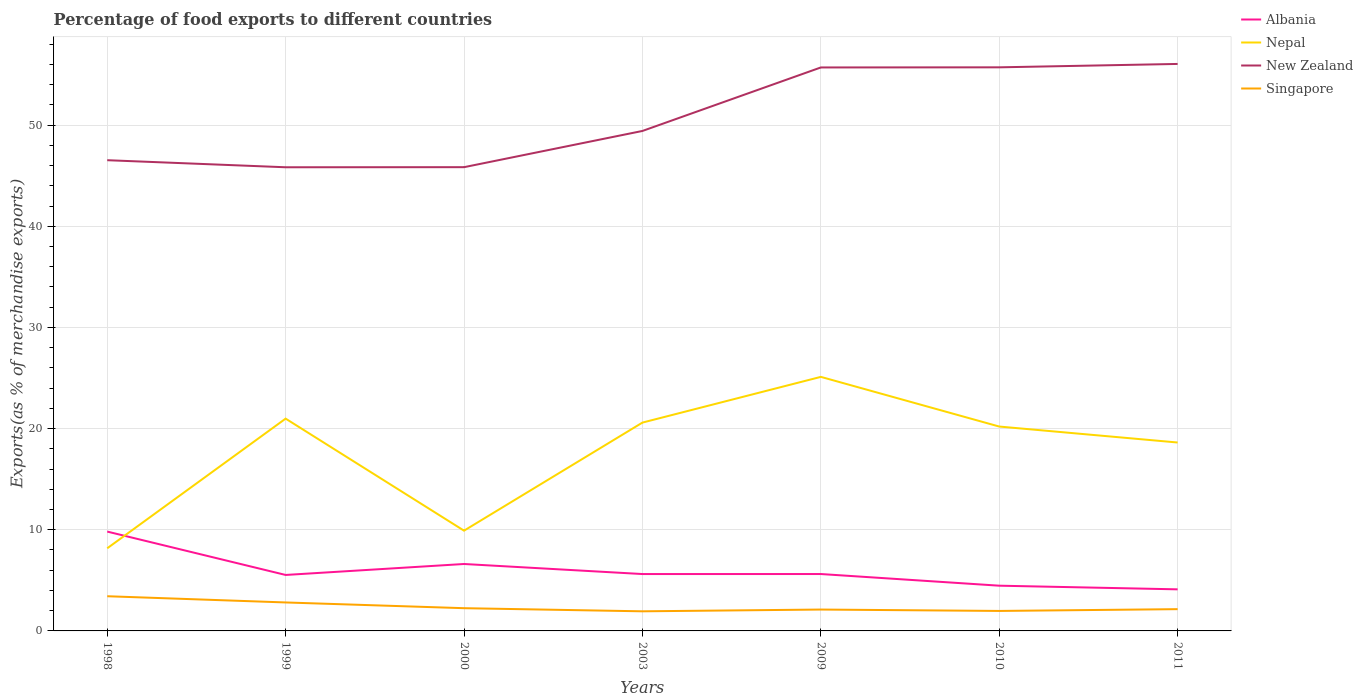Is the number of lines equal to the number of legend labels?
Give a very brief answer. Yes. Across all years, what is the maximum percentage of exports to different countries in New Zealand?
Make the answer very short. 45.83. What is the total percentage of exports to different countries in Nepal in the graph?
Offer a terse response. 0.78. What is the difference between the highest and the second highest percentage of exports to different countries in Albania?
Offer a terse response. 5.71. What is the difference between the highest and the lowest percentage of exports to different countries in Albania?
Provide a short and direct response. 2. Is the percentage of exports to different countries in Albania strictly greater than the percentage of exports to different countries in Nepal over the years?
Provide a succinct answer. No. What is the difference between two consecutive major ticks on the Y-axis?
Your response must be concise. 10. Are the values on the major ticks of Y-axis written in scientific E-notation?
Your answer should be compact. No. Does the graph contain grids?
Your response must be concise. Yes. How many legend labels are there?
Offer a very short reply. 4. How are the legend labels stacked?
Provide a short and direct response. Vertical. What is the title of the graph?
Provide a short and direct response. Percentage of food exports to different countries. What is the label or title of the Y-axis?
Offer a very short reply. Exports(as % of merchandise exports). What is the Exports(as % of merchandise exports) in Albania in 1998?
Make the answer very short. 9.82. What is the Exports(as % of merchandise exports) of Nepal in 1998?
Offer a terse response. 8.17. What is the Exports(as % of merchandise exports) of New Zealand in 1998?
Provide a succinct answer. 46.53. What is the Exports(as % of merchandise exports) of Singapore in 1998?
Your answer should be compact. 3.43. What is the Exports(as % of merchandise exports) of Albania in 1999?
Provide a succinct answer. 5.53. What is the Exports(as % of merchandise exports) of Nepal in 1999?
Ensure brevity in your answer.  20.99. What is the Exports(as % of merchandise exports) in New Zealand in 1999?
Your answer should be very brief. 45.83. What is the Exports(as % of merchandise exports) in Singapore in 1999?
Your response must be concise. 2.81. What is the Exports(as % of merchandise exports) in Albania in 2000?
Provide a short and direct response. 6.62. What is the Exports(as % of merchandise exports) of Nepal in 2000?
Make the answer very short. 9.91. What is the Exports(as % of merchandise exports) in New Zealand in 2000?
Provide a succinct answer. 45.84. What is the Exports(as % of merchandise exports) in Singapore in 2000?
Offer a terse response. 2.25. What is the Exports(as % of merchandise exports) of Albania in 2003?
Offer a terse response. 5.62. What is the Exports(as % of merchandise exports) in Nepal in 2003?
Ensure brevity in your answer.  20.59. What is the Exports(as % of merchandise exports) in New Zealand in 2003?
Ensure brevity in your answer.  49.42. What is the Exports(as % of merchandise exports) of Singapore in 2003?
Your response must be concise. 1.94. What is the Exports(as % of merchandise exports) of Albania in 2009?
Provide a short and direct response. 5.62. What is the Exports(as % of merchandise exports) in Nepal in 2009?
Your answer should be compact. 25.11. What is the Exports(as % of merchandise exports) of New Zealand in 2009?
Provide a succinct answer. 55.7. What is the Exports(as % of merchandise exports) in Singapore in 2009?
Ensure brevity in your answer.  2.11. What is the Exports(as % of merchandise exports) in Albania in 2010?
Your answer should be very brief. 4.47. What is the Exports(as % of merchandise exports) in Nepal in 2010?
Offer a terse response. 20.2. What is the Exports(as % of merchandise exports) of New Zealand in 2010?
Offer a terse response. 55.71. What is the Exports(as % of merchandise exports) of Singapore in 2010?
Your answer should be very brief. 1.98. What is the Exports(as % of merchandise exports) in Albania in 2011?
Provide a short and direct response. 4.11. What is the Exports(as % of merchandise exports) in Nepal in 2011?
Your answer should be compact. 18.63. What is the Exports(as % of merchandise exports) in New Zealand in 2011?
Your answer should be very brief. 56.05. What is the Exports(as % of merchandise exports) in Singapore in 2011?
Offer a very short reply. 2.15. Across all years, what is the maximum Exports(as % of merchandise exports) in Albania?
Offer a terse response. 9.82. Across all years, what is the maximum Exports(as % of merchandise exports) of Nepal?
Offer a terse response. 25.11. Across all years, what is the maximum Exports(as % of merchandise exports) of New Zealand?
Keep it short and to the point. 56.05. Across all years, what is the maximum Exports(as % of merchandise exports) of Singapore?
Ensure brevity in your answer.  3.43. Across all years, what is the minimum Exports(as % of merchandise exports) of Albania?
Your answer should be very brief. 4.11. Across all years, what is the minimum Exports(as % of merchandise exports) of Nepal?
Keep it short and to the point. 8.17. Across all years, what is the minimum Exports(as % of merchandise exports) in New Zealand?
Your response must be concise. 45.83. Across all years, what is the minimum Exports(as % of merchandise exports) in Singapore?
Keep it short and to the point. 1.94. What is the total Exports(as % of merchandise exports) in Albania in the graph?
Your response must be concise. 41.8. What is the total Exports(as % of merchandise exports) in Nepal in the graph?
Your response must be concise. 123.61. What is the total Exports(as % of merchandise exports) of New Zealand in the graph?
Your response must be concise. 355.1. What is the total Exports(as % of merchandise exports) in Singapore in the graph?
Ensure brevity in your answer.  16.67. What is the difference between the Exports(as % of merchandise exports) in Albania in 1998 and that in 1999?
Make the answer very short. 4.29. What is the difference between the Exports(as % of merchandise exports) of Nepal in 1998 and that in 1999?
Provide a succinct answer. -12.82. What is the difference between the Exports(as % of merchandise exports) in New Zealand in 1998 and that in 1999?
Ensure brevity in your answer.  0.7. What is the difference between the Exports(as % of merchandise exports) in Singapore in 1998 and that in 1999?
Keep it short and to the point. 0.61. What is the difference between the Exports(as % of merchandise exports) in Albania in 1998 and that in 2000?
Ensure brevity in your answer.  3.2. What is the difference between the Exports(as % of merchandise exports) of Nepal in 1998 and that in 2000?
Your answer should be compact. -1.74. What is the difference between the Exports(as % of merchandise exports) in New Zealand in 1998 and that in 2000?
Keep it short and to the point. 0.69. What is the difference between the Exports(as % of merchandise exports) of Singapore in 1998 and that in 2000?
Your response must be concise. 1.18. What is the difference between the Exports(as % of merchandise exports) in Albania in 1998 and that in 2003?
Ensure brevity in your answer.  4.2. What is the difference between the Exports(as % of merchandise exports) of Nepal in 1998 and that in 2003?
Your response must be concise. -12.42. What is the difference between the Exports(as % of merchandise exports) of New Zealand in 1998 and that in 2003?
Provide a succinct answer. -2.89. What is the difference between the Exports(as % of merchandise exports) in Singapore in 1998 and that in 2003?
Offer a terse response. 1.49. What is the difference between the Exports(as % of merchandise exports) of Albania in 1998 and that in 2009?
Offer a terse response. 4.2. What is the difference between the Exports(as % of merchandise exports) in Nepal in 1998 and that in 2009?
Your response must be concise. -16.95. What is the difference between the Exports(as % of merchandise exports) of New Zealand in 1998 and that in 2009?
Provide a short and direct response. -9.17. What is the difference between the Exports(as % of merchandise exports) in Singapore in 1998 and that in 2009?
Your response must be concise. 1.32. What is the difference between the Exports(as % of merchandise exports) of Albania in 1998 and that in 2010?
Ensure brevity in your answer.  5.35. What is the difference between the Exports(as % of merchandise exports) in Nepal in 1998 and that in 2010?
Keep it short and to the point. -12.04. What is the difference between the Exports(as % of merchandise exports) of New Zealand in 1998 and that in 2010?
Make the answer very short. -9.18. What is the difference between the Exports(as % of merchandise exports) of Singapore in 1998 and that in 2010?
Ensure brevity in your answer.  1.45. What is the difference between the Exports(as % of merchandise exports) of Albania in 1998 and that in 2011?
Offer a very short reply. 5.71. What is the difference between the Exports(as % of merchandise exports) in Nepal in 1998 and that in 2011?
Your answer should be compact. -10.46. What is the difference between the Exports(as % of merchandise exports) of New Zealand in 1998 and that in 2011?
Keep it short and to the point. -9.52. What is the difference between the Exports(as % of merchandise exports) in Singapore in 1998 and that in 2011?
Make the answer very short. 1.28. What is the difference between the Exports(as % of merchandise exports) of Albania in 1999 and that in 2000?
Make the answer very short. -1.08. What is the difference between the Exports(as % of merchandise exports) of Nepal in 1999 and that in 2000?
Your response must be concise. 11.08. What is the difference between the Exports(as % of merchandise exports) of New Zealand in 1999 and that in 2000?
Offer a very short reply. -0.01. What is the difference between the Exports(as % of merchandise exports) in Singapore in 1999 and that in 2000?
Your answer should be compact. 0.57. What is the difference between the Exports(as % of merchandise exports) in Albania in 1999 and that in 2003?
Ensure brevity in your answer.  -0.09. What is the difference between the Exports(as % of merchandise exports) in Nepal in 1999 and that in 2003?
Give a very brief answer. 0.39. What is the difference between the Exports(as % of merchandise exports) of New Zealand in 1999 and that in 2003?
Offer a very short reply. -3.59. What is the difference between the Exports(as % of merchandise exports) in Singapore in 1999 and that in 2003?
Offer a very short reply. 0.88. What is the difference between the Exports(as % of merchandise exports) of Albania in 1999 and that in 2009?
Your response must be concise. -0.09. What is the difference between the Exports(as % of merchandise exports) in Nepal in 1999 and that in 2009?
Give a very brief answer. -4.13. What is the difference between the Exports(as % of merchandise exports) in New Zealand in 1999 and that in 2009?
Give a very brief answer. -9.87. What is the difference between the Exports(as % of merchandise exports) of Singapore in 1999 and that in 2009?
Your answer should be very brief. 0.7. What is the difference between the Exports(as % of merchandise exports) of Albania in 1999 and that in 2010?
Give a very brief answer. 1.06. What is the difference between the Exports(as % of merchandise exports) in Nepal in 1999 and that in 2010?
Keep it short and to the point. 0.78. What is the difference between the Exports(as % of merchandise exports) in New Zealand in 1999 and that in 2010?
Your response must be concise. -9.88. What is the difference between the Exports(as % of merchandise exports) of Singapore in 1999 and that in 2010?
Ensure brevity in your answer.  0.84. What is the difference between the Exports(as % of merchandise exports) of Albania in 1999 and that in 2011?
Provide a short and direct response. 1.42. What is the difference between the Exports(as % of merchandise exports) of Nepal in 1999 and that in 2011?
Offer a terse response. 2.36. What is the difference between the Exports(as % of merchandise exports) in New Zealand in 1999 and that in 2011?
Provide a short and direct response. -10.21. What is the difference between the Exports(as % of merchandise exports) in Singapore in 1999 and that in 2011?
Provide a short and direct response. 0.66. What is the difference between the Exports(as % of merchandise exports) of Albania in 2000 and that in 2003?
Give a very brief answer. 0.99. What is the difference between the Exports(as % of merchandise exports) of Nepal in 2000 and that in 2003?
Your response must be concise. -10.68. What is the difference between the Exports(as % of merchandise exports) in New Zealand in 2000 and that in 2003?
Keep it short and to the point. -3.58. What is the difference between the Exports(as % of merchandise exports) of Singapore in 2000 and that in 2003?
Keep it short and to the point. 0.31. What is the difference between the Exports(as % of merchandise exports) of Nepal in 2000 and that in 2009?
Keep it short and to the point. -15.2. What is the difference between the Exports(as % of merchandise exports) of New Zealand in 2000 and that in 2009?
Offer a very short reply. -9.86. What is the difference between the Exports(as % of merchandise exports) in Singapore in 2000 and that in 2009?
Offer a terse response. 0.14. What is the difference between the Exports(as % of merchandise exports) of Albania in 2000 and that in 2010?
Your response must be concise. 2.14. What is the difference between the Exports(as % of merchandise exports) of Nepal in 2000 and that in 2010?
Provide a succinct answer. -10.29. What is the difference between the Exports(as % of merchandise exports) of New Zealand in 2000 and that in 2010?
Offer a very short reply. -9.87. What is the difference between the Exports(as % of merchandise exports) of Singapore in 2000 and that in 2010?
Give a very brief answer. 0.27. What is the difference between the Exports(as % of merchandise exports) in Albania in 2000 and that in 2011?
Give a very brief answer. 2.51. What is the difference between the Exports(as % of merchandise exports) of Nepal in 2000 and that in 2011?
Your answer should be compact. -8.71. What is the difference between the Exports(as % of merchandise exports) in New Zealand in 2000 and that in 2011?
Your answer should be very brief. -10.21. What is the difference between the Exports(as % of merchandise exports) in Singapore in 2000 and that in 2011?
Provide a short and direct response. 0.1. What is the difference between the Exports(as % of merchandise exports) of Albania in 2003 and that in 2009?
Provide a short and direct response. -0. What is the difference between the Exports(as % of merchandise exports) of Nepal in 2003 and that in 2009?
Give a very brief answer. -4.52. What is the difference between the Exports(as % of merchandise exports) of New Zealand in 2003 and that in 2009?
Make the answer very short. -6.28. What is the difference between the Exports(as % of merchandise exports) in Singapore in 2003 and that in 2009?
Provide a succinct answer. -0.17. What is the difference between the Exports(as % of merchandise exports) of Albania in 2003 and that in 2010?
Provide a succinct answer. 1.15. What is the difference between the Exports(as % of merchandise exports) of Nepal in 2003 and that in 2010?
Ensure brevity in your answer.  0.39. What is the difference between the Exports(as % of merchandise exports) in New Zealand in 2003 and that in 2010?
Provide a short and direct response. -6.29. What is the difference between the Exports(as % of merchandise exports) of Singapore in 2003 and that in 2010?
Provide a succinct answer. -0.04. What is the difference between the Exports(as % of merchandise exports) of Albania in 2003 and that in 2011?
Give a very brief answer. 1.51. What is the difference between the Exports(as % of merchandise exports) of Nepal in 2003 and that in 2011?
Offer a very short reply. 1.97. What is the difference between the Exports(as % of merchandise exports) in New Zealand in 2003 and that in 2011?
Give a very brief answer. -6.62. What is the difference between the Exports(as % of merchandise exports) in Singapore in 2003 and that in 2011?
Offer a very short reply. -0.21. What is the difference between the Exports(as % of merchandise exports) of Albania in 2009 and that in 2010?
Your response must be concise. 1.15. What is the difference between the Exports(as % of merchandise exports) in Nepal in 2009 and that in 2010?
Ensure brevity in your answer.  4.91. What is the difference between the Exports(as % of merchandise exports) of New Zealand in 2009 and that in 2010?
Your response must be concise. -0.01. What is the difference between the Exports(as % of merchandise exports) of Singapore in 2009 and that in 2010?
Your response must be concise. 0.14. What is the difference between the Exports(as % of merchandise exports) of Albania in 2009 and that in 2011?
Your answer should be very brief. 1.51. What is the difference between the Exports(as % of merchandise exports) of Nepal in 2009 and that in 2011?
Your answer should be very brief. 6.49. What is the difference between the Exports(as % of merchandise exports) in New Zealand in 2009 and that in 2011?
Give a very brief answer. -0.35. What is the difference between the Exports(as % of merchandise exports) of Singapore in 2009 and that in 2011?
Give a very brief answer. -0.04. What is the difference between the Exports(as % of merchandise exports) of Albania in 2010 and that in 2011?
Ensure brevity in your answer.  0.36. What is the difference between the Exports(as % of merchandise exports) in Nepal in 2010 and that in 2011?
Your answer should be very brief. 1.58. What is the difference between the Exports(as % of merchandise exports) of New Zealand in 2010 and that in 2011?
Offer a terse response. -0.33. What is the difference between the Exports(as % of merchandise exports) of Singapore in 2010 and that in 2011?
Keep it short and to the point. -0.18. What is the difference between the Exports(as % of merchandise exports) in Albania in 1998 and the Exports(as % of merchandise exports) in Nepal in 1999?
Keep it short and to the point. -11.17. What is the difference between the Exports(as % of merchandise exports) of Albania in 1998 and the Exports(as % of merchandise exports) of New Zealand in 1999?
Your response must be concise. -36.01. What is the difference between the Exports(as % of merchandise exports) in Albania in 1998 and the Exports(as % of merchandise exports) in Singapore in 1999?
Make the answer very short. 7.01. What is the difference between the Exports(as % of merchandise exports) in Nepal in 1998 and the Exports(as % of merchandise exports) in New Zealand in 1999?
Offer a terse response. -37.66. What is the difference between the Exports(as % of merchandise exports) in Nepal in 1998 and the Exports(as % of merchandise exports) in Singapore in 1999?
Make the answer very short. 5.36. What is the difference between the Exports(as % of merchandise exports) of New Zealand in 1998 and the Exports(as % of merchandise exports) of Singapore in 1999?
Offer a very short reply. 43.72. What is the difference between the Exports(as % of merchandise exports) of Albania in 1998 and the Exports(as % of merchandise exports) of Nepal in 2000?
Your answer should be compact. -0.09. What is the difference between the Exports(as % of merchandise exports) in Albania in 1998 and the Exports(as % of merchandise exports) in New Zealand in 2000?
Offer a very short reply. -36.02. What is the difference between the Exports(as % of merchandise exports) of Albania in 1998 and the Exports(as % of merchandise exports) of Singapore in 2000?
Offer a very short reply. 7.57. What is the difference between the Exports(as % of merchandise exports) in Nepal in 1998 and the Exports(as % of merchandise exports) in New Zealand in 2000?
Give a very brief answer. -37.67. What is the difference between the Exports(as % of merchandise exports) of Nepal in 1998 and the Exports(as % of merchandise exports) of Singapore in 2000?
Your response must be concise. 5.92. What is the difference between the Exports(as % of merchandise exports) in New Zealand in 1998 and the Exports(as % of merchandise exports) in Singapore in 2000?
Your answer should be compact. 44.29. What is the difference between the Exports(as % of merchandise exports) of Albania in 1998 and the Exports(as % of merchandise exports) of Nepal in 2003?
Offer a very short reply. -10.77. What is the difference between the Exports(as % of merchandise exports) in Albania in 1998 and the Exports(as % of merchandise exports) in New Zealand in 2003?
Offer a terse response. -39.6. What is the difference between the Exports(as % of merchandise exports) in Albania in 1998 and the Exports(as % of merchandise exports) in Singapore in 2003?
Your response must be concise. 7.88. What is the difference between the Exports(as % of merchandise exports) of Nepal in 1998 and the Exports(as % of merchandise exports) of New Zealand in 2003?
Offer a very short reply. -41.26. What is the difference between the Exports(as % of merchandise exports) in Nepal in 1998 and the Exports(as % of merchandise exports) in Singapore in 2003?
Ensure brevity in your answer.  6.23. What is the difference between the Exports(as % of merchandise exports) in New Zealand in 1998 and the Exports(as % of merchandise exports) in Singapore in 2003?
Provide a succinct answer. 44.59. What is the difference between the Exports(as % of merchandise exports) in Albania in 1998 and the Exports(as % of merchandise exports) in Nepal in 2009?
Give a very brief answer. -15.29. What is the difference between the Exports(as % of merchandise exports) in Albania in 1998 and the Exports(as % of merchandise exports) in New Zealand in 2009?
Offer a very short reply. -45.88. What is the difference between the Exports(as % of merchandise exports) in Albania in 1998 and the Exports(as % of merchandise exports) in Singapore in 2009?
Provide a succinct answer. 7.71. What is the difference between the Exports(as % of merchandise exports) in Nepal in 1998 and the Exports(as % of merchandise exports) in New Zealand in 2009?
Offer a terse response. -47.53. What is the difference between the Exports(as % of merchandise exports) of Nepal in 1998 and the Exports(as % of merchandise exports) of Singapore in 2009?
Offer a very short reply. 6.06. What is the difference between the Exports(as % of merchandise exports) of New Zealand in 1998 and the Exports(as % of merchandise exports) of Singapore in 2009?
Your response must be concise. 44.42. What is the difference between the Exports(as % of merchandise exports) of Albania in 1998 and the Exports(as % of merchandise exports) of Nepal in 2010?
Ensure brevity in your answer.  -10.38. What is the difference between the Exports(as % of merchandise exports) of Albania in 1998 and the Exports(as % of merchandise exports) of New Zealand in 2010?
Keep it short and to the point. -45.89. What is the difference between the Exports(as % of merchandise exports) of Albania in 1998 and the Exports(as % of merchandise exports) of Singapore in 2010?
Make the answer very short. 7.84. What is the difference between the Exports(as % of merchandise exports) in Nepal in 1998 and the Exports(as % of merchandise exports) in New Zealand in 2010?
Ensure brevity in your answer.  -47.54. What is the difference between the Exports(as % of merchandise exports) of Nepal in 1998 and the Exports(as % of merchandise exports) of Singapore in 2010?
Make the answer very short. 6.19. What is the difference between the Exports(as % of merchandise exports) in New Zealand in 1998 and the Exports(as % of merchandise exports) in Singapore in 2010?
Provide a short and direct response. 44.56. What is the difference between the Exports(as % of merchandise exports) of Albania in 1998 and the Exports(as % of merchandise exports) of Nepal in 2011?
Your answer should be very brief. -8.8. What is the difference between the Exports(as % of merchandise exports) of Albania in 1998 and the Exports(as % of merchandise exports) of New Zealand in 2011?
Your answer should be very brief. -46.23. What is the difference between the Exports(as % of merchandise exports) in Albania in 1998 and the Exports(as % of merchandise exports) in Singapore in 2011?
Give a very brief answer. 7.67. What is the difference between the Exports(as % of merchandise exports) in Nepal in 1998 and the Exports(as % of merchandise exports) in New Zealand in 2011?
Provide a short and direct response. -47.88. What is the difference between the Exports(as % of merchandise exports) of Nepal in 1998 and the Exports(as % of merchandise exports) of Singapore in 2011?
Make the answer very short. 6.02. What is the difference between the Exports(as % of merchandise exports) of New Zealand in 1998 and the Exports(as % of merchandise exports) of Singapore in 2011?
Your response must be concise. 44.38. What is the difference between the Exports(as % of merchandise exports) of Albania in 1999 and the Exports(as % of merchandise exports) of Nepal in 2000?
Ensure brevity in your answer.  -4.38. What is the difference between the Exports(as % of merchandise exports) in Albania in 1999 and the Exports(as % of merchandise exports) in New Zealand in 2000?
Provide a short and direct response. -40.31. What is the difference between the Exports(as % of merchandise exports) in Albania in 1999 and the Exports(as % of merchandise exports) in Singapore in 2000?
Offer a terse response. 3.29. What is the difference between the Exports(as % of merchandise exports) of Nepal in 1999 and the Exports(as % of merchandise exports) of New Zealand in 2000?
Offer a terse response. -24.86. What is the difference between the Exports(as % of merchandise exports) in Nepal in 1999 and the Exports(as % of merchandise exports) in Singapore in 2000?
Your answer should be very brief. 18.74. What is the difference between the Exports(as % of merchandise exports) of New Zealand in 1999 and the Exports(as % of merchandise exports) of Singapore in 2000?
Your response must be concise. 43.59. What is the difference between the Exports(as % of merchandise exports) of Albania in 1999 and the Exports(as % of merchandise exports) of Nepal in 2003?
Offer a very short reply. -15.06. What is the difference between the Exports(as % of merchandise exports) of Albania in 1999 and the Exports(as % of merchandise exports) of New Zealand in 2003?
Your answer should be compact. -43.89. What is the difference between the Exports(as % of merchandise exports) of Albania in 1999 and the Exports(as % of merchandise exports) of Singapore in 2003?
Make the answer very short. 3.59. What is the difference between the Exports(as % of merchandise exports) of Nepal in 1999 and the Exports(as % of merchandise exports) of New Zealand in 2003?
Offer a very short reply. -28.44. What is the difference between the Exports(as % of merchandise exports) in Nepal in 1999 and the Exports(as % of merchandise exports) in Singapore in 2003?
Keep it short and to the point. 19.05. What is the difference between the Exports(as % of merchandise exports) of New Zealand in 1999 and the Exports(as % of merchandise exports) of Singapore in 2003?
Offer a very short reply. 43.9. What is the difference between the Exports(as % of merchandise exports) of Albania in 1999 and the Exports(as % of merchandise exports) of Nepal in 2009?
Give a very brief answer. -19.58. What is the difference between the Exports(as % of merchandise exports) in Albania in 1999 and the Exports(as % of merchandise exports) in New Zealand in 2009?
Your response must be concise. -50.17. What is the difference between the Exports(as % of merchandise exports) in Albania in 1999 and the Exports(as % of merchandise exports) in Singapore in 2009?
Your response must be concise. 3.42. What is the difference between the Exports(as % of merchandise exports) of Nepal in 1999 and the Exports(as % of merchandise exports) of New Zealand in 2009?
Keep it short and to the point. -34.71. What is the difference between the Exports(as % of merchandise exports) of Nepal in 1999 and the Exports(as % of merchandise exports) of Singapore in 2009?
Your answer should be very brief. 18.87. What is the difference between the Exports(as % of merchandise exports) of New Zealand in 1999 and the Exports(as % of merchandise exports) of Singapore in 2009?
Your answer should be very brief. 43.72. What is the difference between the Exports(as % of merchandise exports) in Albania in 1999 and the Exports(as % of merchandise exports) in Nepal in 2010?
Make the answer very short. -14.67. What is the difference between the Exports(as % of merchandise exports) of Albania in 1999 and the Exports(as % of merchandise exports) of New Zealand in 2010?
Provide a short and direct response. -50.18. What is the difference between the Exports(as % of merchandise exports) in Albania in 1999 and the Exports(as % of merchandise exports) in Singapore in 2010?
Make the answer very short. 3.56. What is the difference between the Exports(as % of merchandise exports) in Nepal in 1999 and the Exports(as % of merchandise exports) in New Zealand in 2010?
Keep it short and to the point. -34.73. What is the difference between the Exports(as % of merchandise exports) of Nepal in 1999 and the Exports(as % of merchandise exports) of Singapore in 2010?
Ensure brevity in your answer.  19.01. What is the difference between the Exports(as % of merchandise exports) of New Zealand in 1999 and the Exports(as % of merchandise exports) of Singapore in 2010?
Offer a very short reply. 43.86. What is the difference between the Exports(as % of merchandise exports) of Albania in 1999 and the Exports(as % of merchandise exports) of Nepal in 2011?
Make the answer very short. -13.09. What is the difference between the Exports(as % of merchandise exports) in Albania in 1999 and the Exports(as % of merchandise exports) in New Zealand in 2011?
Make the answer very short. -50.52. What is the difference between the Exports(as % of merchandise exports) of Albania in 1999 and the Exports(as % of merchandise exports) of Singapore in 2011?
Provide a short and direct response. 3.38. What is the difference between the Exports(as % of merchandise exports) of Nepal in 1999 and the Exports(as % of merchandise exports) of New Zealand in 2011?
Provide a succinct answer. -35.06. What is the difference between the Exports(as % of merchandise exports) of Nepal in 1999 and the Exports(as % of merchandise exports) of Singapore in 2011?
Provide a short and direct response. 18.83. What is the difference between the Exports(as % of merchandise exports) in New Zealand in 1999 and the Exports(as % of merchandise exports) in Singapore in 2011?
Give a very brief answer. 43.68. What is the difference between the Exports(as % of merchandise exports) in Albania in 2000 and the Exports(as % of merchandise exports) in Nepal in 2003?
Offer a terse response. -13.98. What is the difference between the Exports(as % of merchandise exports) of Albania in 2000 and the Exports(as % of merchandise exports) of New Zealand in 2003?
Provide a succinct answer. -42.81. What is the difference between the Exports(as % of merchandise exports) in Albania in 2000 and the Exports(as % of merchandise exports) in Singapore in 2003?
Offer a very short reply. 4.68. What is the difference between the Exports(as % of merchandise exports) in Nepal in 2000 and the Exports(as % of merchandise exports) in New Zealand in 2003?
Make the answer very short. -39.51. What is the difference between the Exports(as % of merchandise exports) in Nepal in 2000 and the Exports(as % of merchandise exports) in Singapore in 2003?
Your answer should be very brief. 7.97. What is the difference between the Exports(as % of merchandise exports) of New Zealand in 2000 and the Exports(as % of merchandise exports) of Singapore in 2003?
Offer a terse response. 43.91. What is the difference between the Exports(as % of merchandise exports) in Albania in 2000 and the Exports(as % of merchandise exports) in Nepal in 2009?
Offer a terse response. -18.5. What is the difference between the Exports(as % of merchandise exports) of Albania in 2000 and the Exports(as % of merchandise exports) of New Zealand in 2009?
Provide a short and direct response. -49.09. What is the difference between the Exports(as % of merchandise exports) of Albania in 2000 and the Exports(as % of merchandise exports) of Singapore in 2009?
Your response must be concise. 4.5. What is the difference between the Exports(as % of merchandise exports) in Nepal in 2000 and the Exports(as % of merchandise exports) in New Zealand in 2009?
Provide a short and direct response. -45.79. What is the difference between the Exports(as % of merchandise exports) of Nepal in 2000 and the Exports(as % of merchandise exports) of Singapore in 2009?
Your answer should be compact. 7.8. What is the difference between the Exports(as % of merchandise exports) of New Zealand in 2000 and the Exports(as % of merchandise exports) of Singapore in 2009?
Provide a succinct answer. 43.73. What is the difference between the Exports(as % of merchandise exports) in Albania in 2000 and the Exports(as % of merchandise exports) in Nepal in 2010?
Keep it short and to the point. -13.59. What is the difference between the Exports(as % of merchandise exports) in Albania in 2000 and the Exports(as % of merchandise exports) in New Zealand in 2010?
Offer a very short reply. -49.1. What is the difference between the Exports(as % of merchandise exports) of Albania in 2000 and the Exports(as % of merchandise exports) of Singapore in 2010?
Your answer should be compact. 4.64. What is the difference between the Exports(as % of merchandise exports) in Nepal in 2000 and the Exports(as % of merchandise exports) in New Zealand in 2010?
Provide a short and direct response. -45.8. What is the difference between the Exports(as % of merchandise exports) in Nepal in 2000 and the Exports(as % of merchandise exports) in Singapore in 2010?
Ensure brevity in your answer.  7.94. What is the difference between the Exports(as % of merchandise exports) in New Zealand in 2000 and the Exports(as % of merchandise exports) in Singapore in 2010?
Your response must be concise. 43.87. What is the difference between the Exports(as % of merchandise exports) of Albania in 2000 and the Exports(as % of merchandise exports) of Nepal in 2011?
Provide a succinct answer. -12.01. What is the difference between the Exports(as % of merchandise exports) of Albania in 2000 and the Exports(as % of merchandise exports) of New Zealand in 2011?
Keep it short and to the point. -49.43. What is the difference between the Exports(as % of merchandise exports) in Albania in 2000 and the Exports(as % of merchandise exports) in Singapore in 2011?
Provide a short and direct response. 4.46. What is the difference between the Exports(as % of merchandise exports) of Nepal in 2000 and the Exports(as % of merchandise exports) of New Zealand in 2011?
Make the answer very short. -46.14. What is the difference between the Exports(as % of merchandise exports) of Nepal in 2000 and the Exports(as % of merchandise exports) of Singapore in 2011?
Your answer should be compact. 7.76. What is the difference between the Exports(as % of merchandise exports) of New Zealand in 2000 and the Exports(as % of merchandise exports) of Singapore in 2011?
Provide a short and direct response. 43.69. What is the difference between the Exports(as % of merchandise exports) of Albania in 2003 and the Exports(as % of merchandise exports) of Nepal in 2009?
Your answer should be compact. -19.49. What is the difference between the Exports(as % of merchandise exports) in Albania in 2003 and the Exports(as % of merchandise exports) in New Zealand in 2009?
Offer a terse response. -50.08. What is the difference between the Exports(as % of merchandise exports) in Albania in 2003 and the Exports(as % of merchandise exports) in Singapore in 2009?
Provide a short and direct response. 3.51. What is the difference between the Exports(as % of merchandise exports) of Nepal in 2003 and the Exports(as % of merchandise exports) of New Zealand in 2009?
Make the answer very short. -35.11. What is the difference between the Exports(as % of merchandise exports) in Nepal in 2003 and the Exports(as % of merchandise exports) in Singapore in 2009?
Your response must be concise. 18.48. What is the difference between the Exports(as % of merchandise exports) in New Zealand in 2003 and the Exports(as % of merchandise exports) in Singapore in 2009?
Your response must be concise. 47.31. What is the difference between the Exports(as % of merchandise exports) of Albania in 2003 and the Exports(as % of merchandise exports) of Nepal in 2010?
Your response must be concise. -14.58. What is the difference between the Exports(as % of merchandise exports) in Albania in 2003 and the Exports(as % of merchandise exports) in New Zealand in 2010?
Provide a short and direct response. -50.09. What is the difference between the Exports(as % of merchandise exports) in Albania in 2003 and the Exports(as % of merchandise exports) in Singapore in 2010?
Make the answer very short. 3.65. What is the difference between the Exports(as % of merchandise exports) in Nepal in 2003 and the Exports(as % of merchandise exports) in New Zealand in 2010?
Your response must be concise. -35.12. What is the difference between the Exports(as % of merchandise exports) in Nepal in 2003 and the Exports(as % of merchandise exports) in Singapore in 2010?
Provide a short and direct response. 18.62. What is the difference between the Exports(as % of merchandise exports) in New Zealand in 2003 and the Exports(as % of merchandise exports) in Singapore in 2010?
Keep it short and to the point. 47.45. What is the difference between the Exports(as % of merchandise exports) in Albania in 2003 and the Exports(as % of merchandise exports) in Nepal in 2011?
Your answer should be compact. -13. What is the difference between the Exports(as % of merchandise exports) in Albania in 2003 and the Exports(as % of merchandise exports) in New Zealand in 2011?
Offer a very short reply. -50.43. What is the difference between the Exports(as % of merchandise exports) in Albania in 2003 and the Exports(as % of merchandise exports) in Singapore in 2011?
Your answer should be very brief. 3.47. What is the difference between the Exports(as % of merchandise exports) in Nepal in 2003 and the Exports(as % of merchandise exports) in New Zealand in 2011?
Offer a terse response. -35.45. What is the difference between the Exports(as % of merchandise exports) in Nepal in 2003 and the Exports(as % of merchandise exports) in Singapore in 2011?
Provide a short and direct response. 18.44. What is the difference between the Exports(as % of merchandise exports) of New Zealand in 2003 and the Exports(as % of merchandise exports) of Singapore in 2011?
Provide a succinct answer. 47.27. What is the difference between the Exports(as % of merchandise exports) of Albania in 2009 and the Exports(as % of merchandise exports) of Nepal in 2010?
Provide a short and direct response. -14.58. What is the difference between the Exports(as % of merchandise exports) in Albania in 2009 and the Exports(as % of merchandise exports) in New Zealand in 2010?
Offer a very short reply. -50.09. What is the difference between the Exports(as % of merchandise exports) of Albania in 2009 and the Exports(as % of merchandise exports) of Singapore in 2010?
Provide a succinct answer. 3.65. What is the difference between the Exports(as % of merchandise exports) of Nepal in 2009 and the Exports(as % of merchandise exports) of New Zealand in 2010?
Ensure brevity in your answer.  -30.6. What is the difference between the Exports(as % of merchandise exports) in Nepal in 2009 and the Exports(as % of merchandise exports) in Singapore in 2010?
Provide a short and direct response. 23.14. What is the difference between the Exports(as % of merchandise exports) of New Zealand in 2009 and the Exports(as % of merchandise exports) of Singapore in 2010?
Provide a succinct answer. 53.73. What is the difference between the Exports(as % of merchandise exports) in Albania in 2009 and the Exports(as % of merchandise exports) in Nepal in 2011?
Offer a terse response. -13. What is the difference between the Exports(as % of merchandise exports) in Albania in 2009 and the Exports(as % of merchandise exports) in New Zealand in 2011?
Keep it short and to the point. -50.42. What is the difference between the Exports(as % of merchandise exports) in Albania in 2009 and the Exports(as % of merchandise exports) in Singapore in 2011?
Provide a succinct answer. 3.47. What is the difference between the Exports(as % of merchandise exports) of Nepal in 2009 and the Exports(as % of merchandise exports) of New Zealand in 2011?
Keep it short and to the point. -30.93. What is the difference between the Exports(as % of merchandise exports) of Nepal in 2009 and the Exports(as % of merchandise exports) of Singapore in 2011?
Give a very brief answer. 22.96. What is the difference between the Exports(as % of merchandise exports) of New Zealand in 2009 and the Exports(as % of merchandise exports) of Singapore in 2011?
Keep it short and to the point. 53.55. What is the difference between the Exports(as % of merchandise exports) in Albania in 2010 and the Exports(as % of merchandise exports) in Nepal in 2011?
Give a very brief answer. -14.15. What is the difference between the Exports(as % of merchandise exports) in Albania in 2010 and the Exports(as % of merchandise exports) in New Zealand in 2011?
Provide a short and direct response. -51.58. What is the difference between the Exports(as % of merchandise exports) in Albania in 2010 and the Exports(as % of merchandise exports) in Singapore in 2011?
Provide a short and direct response. 2.32. What is the difference between the Exports(as % of merchandise exports) of Nepal in 2010 and the Exports(as % of merchandise exports) of New Zealand in 2011?
Make the answer very short. -35.84. What is the difference between the Exports(as % of merchandise exports) in Nepal in 2010 and the Exports(as % of merchandise exports) in Singapore in 2011?
Keep it short and to the point. 18.05. What is the difference between the Exports(as % of merchandise exports) of New Zealand in 2010 and the Exports(as % of merchandise exports) of Singapore in 2011?
Provide a succinct answer. 53.56. What is the average Exports(as % of merchandise exports) in Albania per year?
Your answer should be very brief. 5.97. What is the average Exports(as % of merchandise exports) of Nepal per year?
Offer a terse response. 17.66. What is the average Exports(as % of merchandise exports) of New Zealand per year?
Make the answer very short. 50.73. What is the average Exports(as % of merchandise exports) in Singapore per year?
Make the answer very short. 2.38. In the year 1998, what is the difference between the Exports(as % of merchandise exports) in Albania and Exports(as % of merchandise exports) in Nepal?
Make the answer very short. 1.65. In the year 1998, what is the difference between the Exports(as % of merchandise exports) of Albania and Exports(as % of merchandise exports) of New Zealand?
Keep it short and to the point. -36.71. In the year 1998, what is the difference between the Exports(as % of merchandise exports) of Albania and Exports(as % of merchandise exports) of Singapore?
Keep it short and to the point. 6.39. In the year 1998, what is the difference between the Exports(as % of merchandise exports) in Nepal and Exports(as % of merchandise exports) in New Zealand?
Ensure brevity in your answer.  -38.36. In the year 1998, what is the difference between the Exports(as % of merchandise exports) in Nepal and Exports(as % of merchandise exports) in Singapore?
Your answer should be compact. 4.74. In the year 1998, what is the difference between the Exports(as % of merchandise exports) of New Zealand and Exports(as % of merchandise exports) of Singapore?
Give a very brief answer. 43.1. In the year 1999, what is the difference between the Exports(as % of merchandise exports) in Albania and Exports(as % of merchandise exports) in Nepal?
Your response must be concise. -15.45. In the year 1999, what is the difference between the Exports(as % of merchandise exports) of Albania and Exports(as % of merchandise exports) of New Zealand?
Offer a very short reply. -40.3. In the year 1999, what is the difference between the Exports(as % of merchandise exports) in Albania and Exports(as % of merchandise exports) in Singapore?
Keep it short and to the point. 2.72. In the year 1999, what is the difference between the Exports(as % of merchandise exports) of Nepal and Exports(as % of merchandise exports) of New Zealand?
Ensure brevity in your answer.  -24.85. In the year 1999, what is the difference between the Exports(as % of merchandise exports) of Nepal and Exports(as % of merchandise exports) of Singapore?
Your answer should be very brief. 18.17. In the year 1999, what is the difference between the Exports(as % of merchandise exports) in New Zealand and Exports(as % of merchandise exports) in Singapore?
Offer a very short reply. 43.02. In the year 2000, what is the difference between the Exports(as % of merchandise exports) in Albania and Exports(as % of merchandise exports) in Nepal?
Give a very brief answer. -3.29. In the year 2000, what is the difference between the Exports(as % of merchandise exports) in Albania and Exports(as % of merchandise exports) in New Zealand?
Your answer should be compact. -39.23. In the year 2000, what is the difference between the Exports(as % of merchandise exports) in Albania and Exports(as % of merchandise exports) in Singapore?
Make the answer very short. 4.37. In the year 2000, what is the difference between the Exports(as % of merchandise exports) of Nepal and Exports(as % of merchandise exports) of New Zealand?
Your response must be concise. -35.93. In the year 2000, what is the difference between the Exports(as % of merchandise exports) of Nepal and Exports(as % of merchandise exports) of Singapore?
Offer a terse response. 7.66. In the year 2000, what is the difference between the Exports(as % of merchandise exports) in New Zealand and Exports(as % of merchandise exports) in Singapore?
Provide a short and direct response. 43.6. In the year 2003, what is the difference between the Exports(as % of merchandise exports) in Albania and Exports(as % of merchandise exports) in Nepal?
Your answer should be very brief. -14.97. In the year 2003, what is the difference between the Exports(as % of merchandise exports) in Albania and Exports(as % of merchandise exports) in New Zealand?
Give a very brief answer. -43.8. In the year 2003, what is the difference between the Exports(as % of merchandise exports) of Albania and Exports(as % of merchandise exports) of Singapore?
Your answer should be compact. 3.68. In the year 2003, what is the difference between the Exports(as % of merchandise exports) in Nepal and Exports(as % of merchandise exports) in New Zealand?
Provide a succinct answer. -28.83. In the year 2003, what is the difference between the Exports(as % of merchandise exports) of Nepal and Exports(as % of merchandise exports) of Singapore?
Give a very brief answer. 18.66. In the year 2003, what is the difference between the Exports(as % of merchandise exports) in New Zealand and Exports(as % of merchandise exports) in Singapore?
Keep it short and to the point. 47.49. In the year 2009, what is the difference between the Exports(as % of merchandise exports) of Albania and Exports(as % of merchandise exports) of Nepal?
Provide a short and direct response. -19.49. In the year 2009, what is the difference between the Exports(as % of merchandise exports) of Albania and Exports(as % of merchandise exports) of New Zealand?
Your answer should be very brief. -50.08. In the year 2009, what is the difference between the Exports(as % of merchandise exports) in Albania and Exports(as % of merchandise exports) in Singapore?
Give a very brief answer. 3.51. In the year 2009, what is the difference between the Exports(as % of merchandise exports) in Nepal and Exports(as % of merchandise exports) in New Zealand?
Give a very brief answer. -30.59. In the year 2009, what is the difference between the Exports(as % of merchandise exports) in Nepal and Exports(as % of merchandise exports) in Singapore?
Offer a terse response. 23. In the year 2009, what is the difference between the Exports(as % of merchandise exports) of New Zealand and Exports(as % of merchandise exports) of Singapore?
Provide a short and direct response. 53.59. In the year 2010, what is the difference between the Exports(as % of merchandise exports) in Albania and Exports(as % of merchandise exports) in Nepal?
Offer a terse response. -15.73. In the year 2010, what is the difference between the Exports(as % of merchandise exports) of Albania and Exports(as % of merchandise exports) of New Zealand?
Offer a very short reply. -51.24. In the year 2010, what is the difference between the Exports(as % of merchandise exports) of Albania and Exports(as % of merchandise exports) of Singapore?
Provide a succinct answer. 2.5. In the year 2010, what is the difference between the Exports(as % of merchandise exports) of Nepal and Exports(as % of merchandise exports) of New Zealand?
Provide a short and direct response. -35.51. In the year 2010, what is the difference between the Exports(as % of merchandise exports) in Nepal and Exports(as % of merchandise exports) in Singapore?
Provide a short and direct response. 18.23. In the year 2010, what is the difference between the Exports(as % of merchandise exports) of New Zealand and Exports(as % of merchandise exports) of Singapore?
Offer a very short reply. 53.74. In the year 2011, what is the difference between the Exports(as % of merchandise exports) in Albania and Exports(as % of merchandise exports) in Nepal?
Your response must be concise. -14.52. In the year 2011, what is the difference between the Exports(as % of merchandise exports) in Albania and Exports(as % of merchandise exports) in New Zealand?
Offer a terse response. -51.94. In the year 2011, what is the difference between the Exports(as % of merchandise exports) of Albania and Exports(as % of merchandise exports) of Singapore?
Your answer should be compact. 1.96. In the year 2011, what is the difference between the Exports(as % of merchandise exports) in Nepal and Exports(as % of merchandise exports) in New Zealand?
Your response must be concise. -37.42. In the year 2011, what is the difference between the Exports(as % of merchandise exports) of Nepal and Exports(as % of merchandise exports) of Singapore?
Your response must be concise. 16.47. In the year 2011, what is the difference between the Exports(as % of merchandise exports) in New Zealand and Exports(as % of merchandise exports) in Singapore?
Your response must be concise. 53.9. What is the ratio of the Exports(as % of merchandise exports) in Albania in 1998 to that in 1999?
Your answer should be compact. 1.77. What is the ratio of the Exports(as % of merchandise exports) of Nepal in 1998 to that in 1999?
Offer a terse response. 0.39. What is the ratio of the Exports(as % of merchandise exports) in New Zealand in 1998 to that in 1999?
Provide a short and direct response. 1.02. What is the ratio of the Exports(as % of merchandise exports) in Singapore in 1998 to that in 1999?
Your answer should be compact. 1.22. What is the ratio of the Exports(as % of merchandise exports) of Albania in 1998 to that in 2000?
Ensure brevity in your answer.  1.48. What is the ratio of the Exports(as % of merchandise exports) of Nepal in 1998 to that in 2000?
Offer a very short reply. 0.82. What is the ratio of the Exports(as % of merchandise exports) of Singapore in 1998 to that in 2000?
Offer a terse response. 1.53. What is the ratio of the Exports(as % of merchandise exports) of Albania in 1998 to that in 2003?
Your answer should be very brief. 1.75. What is the ratio of the Exports(as % of merchandise exports) in Nepal in 1998 to that in 2003?
Ensure brevity in your answer.  0.4. What is the ratio of the Exports(as % of merchandise exports) in New Zealand in 1998 to that in 2003?
Make the answer very short. 0.94. What is the ratio of the Exports(as % of merchandise exports) in Singapore in 1998 to that in 2003?
Your response must be concise. 1.77. What is the ratio of the Exports(as % of merchandise exports) of Albania in 1998 to that in 2009?
Offer a very short reply. 1.75. What is the ratio of the Exports(as % of merchandise exports) in Nepal in 1998 to that in 2009?
Your response must be concise. 0.33. What is the ratio of the Exports(as % of merchandise exports) in New Zealand in 1998 to that in 2009?
Provide a succinct answer. 0.84. What is the ratio of the Exports(as % of merchandise exports) of Singapore in 1998 to that in 2009?
Your answer should be compact. 1.62. What is the ratio of the Exports(as % of merchandise exports) in Albania in 1998 to that in 2010?
Provide a succinct answer. 2.2. What is the ratio of the Exports(as % of merchandise exports) in Nepal in 1998 to that in 2010?
Offer a terse response. 0.4. What is the ratio of the Exports(as % of merchandise exports) in New Zealand in 1998 to that in 2010?
Offer a very short reply. 0.84. What is the ratio of the Exports(as % of merchandise exports) in Singapore in 1998 to that in 2010?
Keep it short and to the point. 1.74. What is the ratio of the Exports(as % of merchandise exports) of Albania in 1998 to that in 2011?
Ensure brevity in your answer.  2.39. What is the ratio of the Exports(as % of merchandise exports) in Nepal in 1998 to that in 2011?
Ensure brevity in your answer.  0.44. What is the ratio of the Exports(as % of merchandise exports) of New Zealand in 1998 to that in 2011?
Offer a terse response. 0.83. What is the ratio of the Exports(as % of merchandise exports) of Singapore in 1998 to that in 2011?
Provide a succinct answer. 1.59. What is the ratio of the Exports(as % of merchandise exports) in Albania in 1999 to that in 2000?
Your answer should be compact. 0.84. What is the ratio of the Exports(as % of merchandise exports) in Nepal in 1999 to that in 2000?
Provide a succinct answer. 2.12. What is the ratio of the Exports(as % of merchandise exports) of New Zealand in 1999 to that in 2000?
Your answer should be compact. 1. What is the ratio of the Exports(as % of merchandise exports) in Singapore in 1999 to that in 2000?
Make the answer very short. 1.25. What is the ratio of the Exports(as % of merchandise exports) of Albania in 1999 to that in 2003?
Ensure brevity in your answer.  0.98. What is the ratio of the Exports(as % of merchandise exports) of Nepal in 1999 to that in 2003?
Your answer should be very brief. 1.02. What is the ratio of the Exports(as % of merchandise exports) in New Zealand in 1999 to that in 2003?
Keep it short and to the point. 0.93. What is the ratio of the Exports(as % of merchandise exports) of Singapore in 1999 to that in 2003?
Give a very brief answer. 1.45. What is the ratio of the Exports(as % of merchandise exports) of Albania in 1999 to that in 2009?
Offer a very short reply. 0.98. What is the ratio of the Exports(as % of merchandise exports) in Nepal in 1999 to that in 2009?
Offer a terse response. 0.84. What is the ratio of the Exports(as % of merchandise exports) of New Zealand in 1999 to that in 2009?
Offer a terse response. 0.82. What is the ratio of the Exports(as % of merchandise exports) of Singapore in 1999 to that in 2009?
Your answer should be very brief. 1.33. What is the ratio of the Exports(as % of merchandise exports) of Albania in 1999 to that in 2010?
Provide a short and direct response. 1.24. What is the ratio of the Exports(as % of merchandise exports) in Nepal in 1999 to that in 2010?
Ensure brevity in your answer.  1.04. What is the ratio of the Exports(as % of merchandise exports) in New Zealand in 1999 to that in 2010?
Offer a very short reply. 0.82. What is the ratio of the Exports(as % of merchandise exports) in Singapore in 1999 to that in 2010?
Make the answer very short. 1.42. What is the ratio of the Exports(as % of merchandise exports) of Albania in 1999 to that in 2011?
Keep it short and to the point. 1.35. What is the ratio of the Exports(as % of merchandise exports) in Nepal in 1999 to that in 2011?
Ensure brevity in your answer.  1.13. What is the ratio of the Exports(as % of merchandise exports) of New Zealand in 1999 to that in 2011?
Give a very brief answer. 0.82. What is the ratio of the Exports(as % of merchandise exports) in Singapore in 1999 to that in 2011?
Provide a succinct answer. 1.31. What is the ratio of the Exports(as % of merchandise exports) in Albania in 2000 to that in 2003?
Keep it short and to the point. 1.18. What is the ratio of the Exports(as % of merchandise exports) in Nepal in 2000 to that in 2003?
Provide a succinct answer. 0.48. What is the ratio of the Exports(as % of merchandise exports) of New Zealand in 2000 to that in 2003?
Give a very brief answer. 0.93. What is the ratio of the Exports(as % of merchandise exports) in Singapore in 2000 to that in 2003?
Make the answer very short. 1.16. What is the ratio of the Exports(as % of merchandise exports) of Albania in 2000 to that in 2009?
Your answer should be compact. 1.18. What is the ratio of the Exports(as % of merchandise exports) of Nepal in 2000 to that in 2009?
Give a very brief answer. 0.39. What is the ratio of the Exports(as % of merchandise exports) of New Zealand in 2000 to that in 2009?
Give a very brief answer. 0.82. What is the ratio of the Exports(as % of merchandise exports) of Singapore in 2000 to that in 2009?
Provide a short and direct response. 1.06. What is the ratio of the Exports(as % of merchandise exports) of Albania in 2000 to that in 2010?
Provide a succinct answer. 1.48. What is the ratio of the Exports(as % of merchandise exports) in Nepal in 2000 to that in 2010?
Make the answer very short. 0.49. What is the ratio of the Exports(as % of merchandise exports) of New Zealand in 2000 to that in 2010?
Give a very brief answer. 0.82. What is the ratio of the Exports(as % of merchandise exports) of Singapore in 2000 to that in 2010?
Your response must be concise. 1.14. What is the ratio of the Exports(as % of merchandise exports) in Albania in 2000 to that in 2011?
Keep it short and to the point. 1.61. What is the ratio of the Exports(as % of merchandise exports) of Nepal in 2000 to that in 2011?
Provide a short and direct response. 0.53. What is the ratio of the Exports(as % of merchandise exports) in New Zealand in 2000 to that in 2011?
Make the answer very short. 0.82. What is the ratio of the Exports(as % of merchandise exports) in Singapore in 2000 to that in 2011?
Your response must be concise. 1.04. What is the ratio of the Exports(as % of merchandise exports) of Nepal in 2003 to that in 2009?
Keep it short and to the point. 0.82. What is the ratio of the Exports(as % of merchandise exports) in New Zealand in 2003 to that in 2009?
Make the answer very short. 0.89. What is the ratio of the Exports(as % of merchandise exports) of Singapore in 2003 to that in 2009?
Keep it short and to the point. 0.92. What is the ratio of the Exports(as % of merchandise exports) of Albania in 2003 to that in 2010?
Your answer should be compact. 1.26. What is the ratio of the Exports(as % of merchandise exports) in Nepal in 2003 to that in 2010?
Provide a short and direct response. 1.02. What is the ratio of the Exports(as % of merchandise exports) of New Zealand in 2003 to that in 2010?
Your answer should be compact. 0.89. What is the ratio of the Exports(as % of merchandise exports) in Singapore in 2003 to that in 2010?
Keep it short and to the point. 0.98. What is the ratio of the Exports(as % of merchandise exports) of Albania in 2003 to that in 2011?
Provide a succinct answer. 1.37. What is the ratio of the Exports(as % of merchandise exports) of Nepal in 2003 to that in 2011?
Make the answer very short. 1.11. What is the ratio of the Exports(as % of merchandise exports) of New Zealand in 2003 to that in 2011?
Keep it short and to the point. 0.88. What is the ratio of the Exports(as % of merchandise exports) in Singapore in 2003 to that in 2011?
Your answer should be compact. 0.9. What is the ratio of the Exports(as % of merchandise exports) of Albania in 2009 to that in 2010?
Keep it short and to the point. 1.26. What is the ratio of the Exports(as % of merchandise exports) of Nepal in 2009 to that in 2010?
Your answer should be very brief. 1.24. What is the ratio of the Exports(as % of merchandise exports) in New Zealand in 2009 to that in 2010?
Keep it short and to the point. 1. What is the ratio of the Exports(as % of merchandise exports) of Singapore in 2009 to that in 2010?
Keep it short and to the point. 1.07. What is the ratio of the Exports(as % of merchandise exports) in Albania in 2009 to that in 2011?
Keep it short and to the point. 1.37. What is the ratio of the Exports(as % of merchandise exports) of Nepal in 2009 to that in 2011?
Keep it short and to the point. 1.35. What is the ratio of the Exports(as % of merchandise exports) in Singapore in 2009 to that in 2011?
Your answer should be compact. 0.98. What is the ratio of the Exports(as % of merchandise exports) in Albania in 2010 to that in 2011?
Make the answer very short. 1.09. What is the ratio of the Exports(as % of merchandise exports) in Nepal in 2010 to that in 2011?
Give a very brief answer. 1.08. What is the ratio of the Exports(as % of merchandise exports) in New Zealand in 2010 to that in 2011?
Provide a succinct answer. 0.99. What is the ratio of the Exports(as % of merchandise exports) in Singapore in 2010 to that in 2011?
Provide a short and direct response. 0.92. What is the difference between the highest and the second highest Exports(as % of merchandise exports) of Albania?
Offer a terse response. 3.2. What is the difference between the highest and the second highest Exports(as % of merchandise exports) of Nepal?
Give a very brief answer. 4.13. What is the difference between the highest and the second highest Exports(as % of merchandise exports) of New Zealand?
Ensure brevity in your answer.  0.33. What is the difference between the highest and the second highest Exports(as % of merchandise exports) in Singapore?
Your answer should be compact. 0.61. What is the difference between the highest and the lowest Exports(as % of merchandise exports) of Albania?
Ensure brevity in your answer.  5.71. What is the difference between the highest and the lowest Exports(as % of merchandise exports) of Nepal?
Your response must be concise. 16.95. What is the difference between the highest and the lowest Exports(as % of merchandise exports) in New Zealand?
Make the answer very short. 10.21. What is the difference between the highest and the lowest Exports(as % of merchandise exports) of Singapore?
Your answer should be very brief. 1.49. 